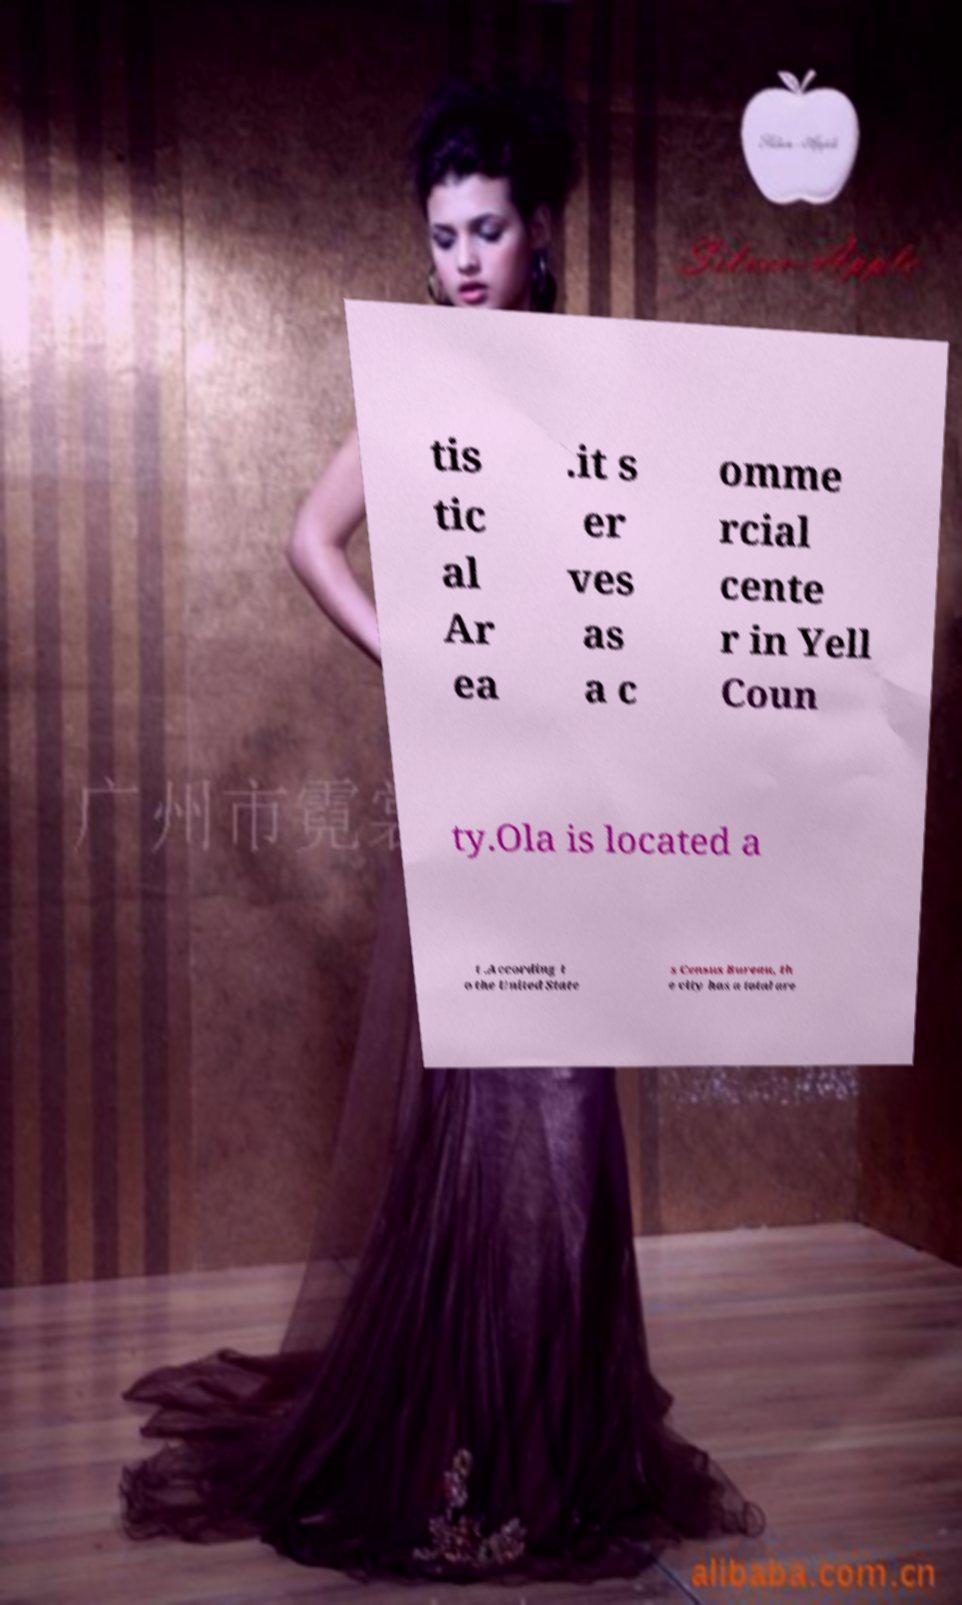For documentation purposes, I need the text within this image transcribed. Could you provide that? tis tic al Ar ea .it s er ves as a c omme rcial cente r in Yell Coun ty.Ola is located a t .According t o the United State s Census Bureau, th e city has a total are 